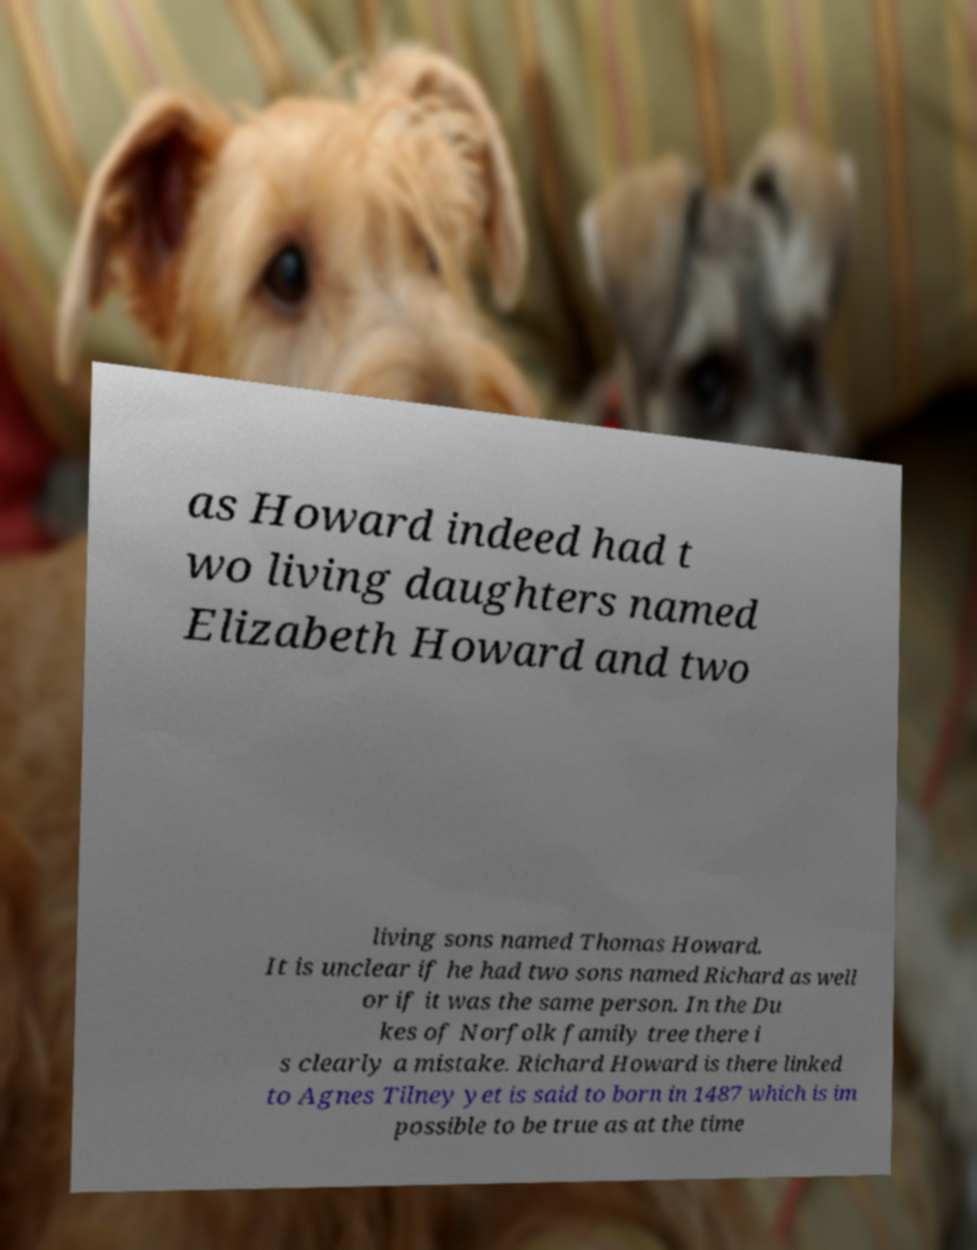There's text embedded in this image that I need extracted. Can you transcribe it verbatim? as Howard indeed had t wo living daughters named Elizabeth Howard and two living sons named Thomas Howard. It is unclear if he had two sons named Richard as well or if it was the same person. In the Du kes of Norfolk family tree there i s clearly a mistake. Richard Howard is there linked to Agnes Tilney yet is said to born in 1487 which is im possible to be true as at the time 